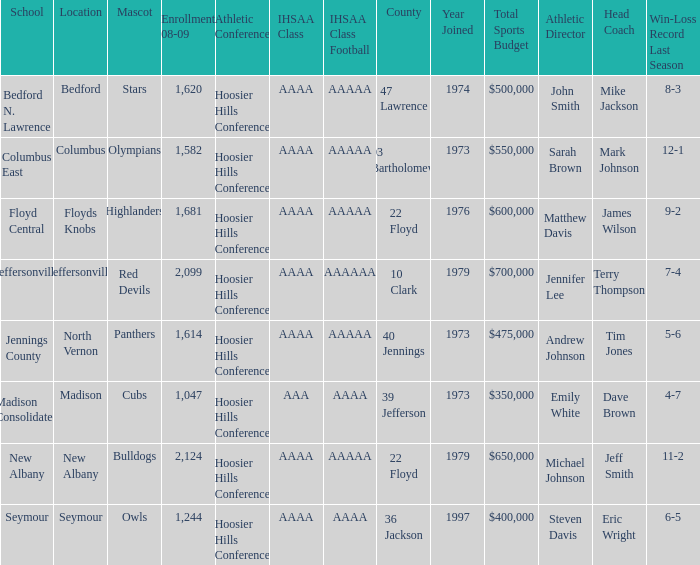What's the IHSAA Class when the school is Seymour? AAAA. 